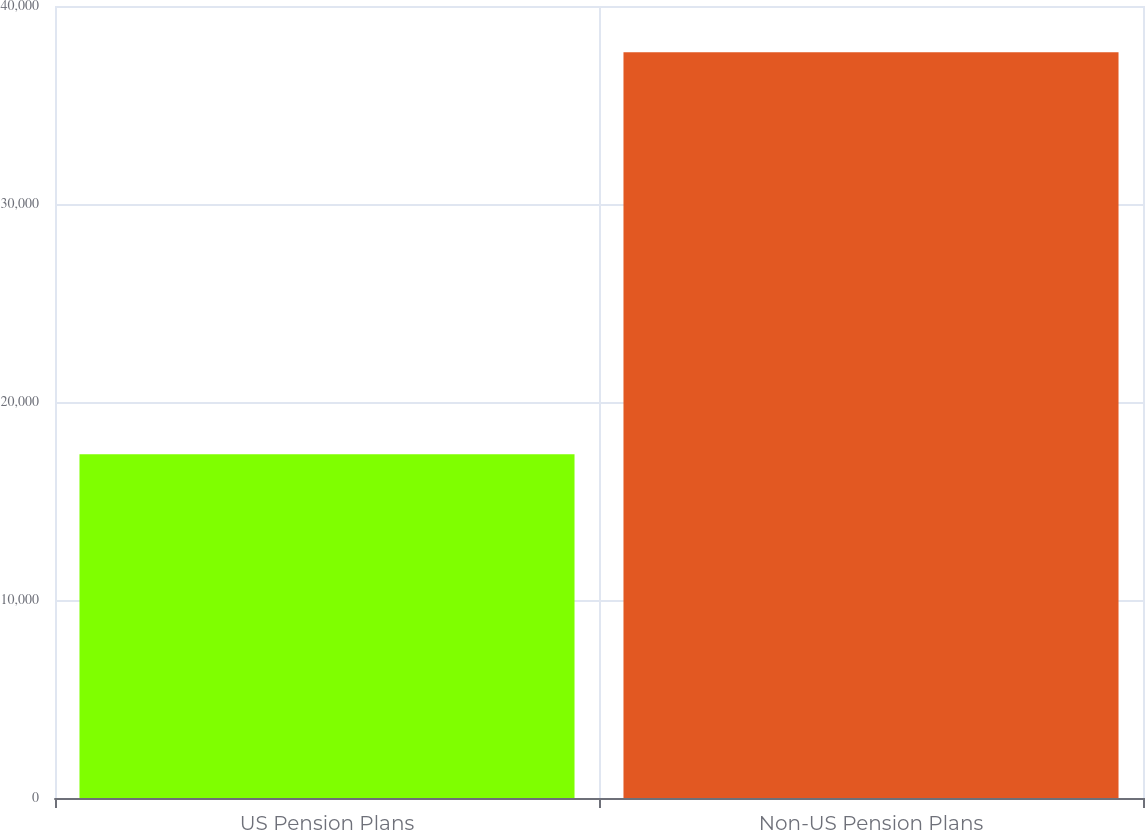<chart> <loc_0><loc_0><loc_500><loc_500><bar_chart><fcel>US Pension Plans<fcel>Non-US Pension Plans<nl><fcel>17359<fcel>37661<nl></chart> 